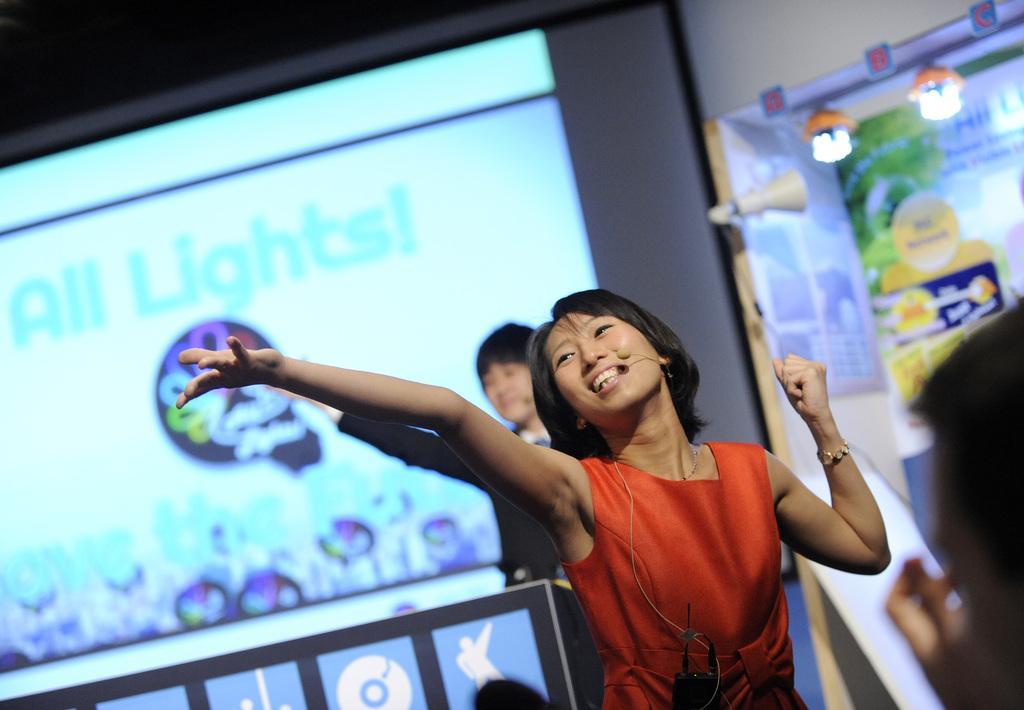How would you summarize this image in a sentence or two? In the foreground of the image there is a lady wearing orange color dress. In the background of the image there is screen. To the right side of the image there is a banner. There is a person. At the top of the image there is ceiling. 